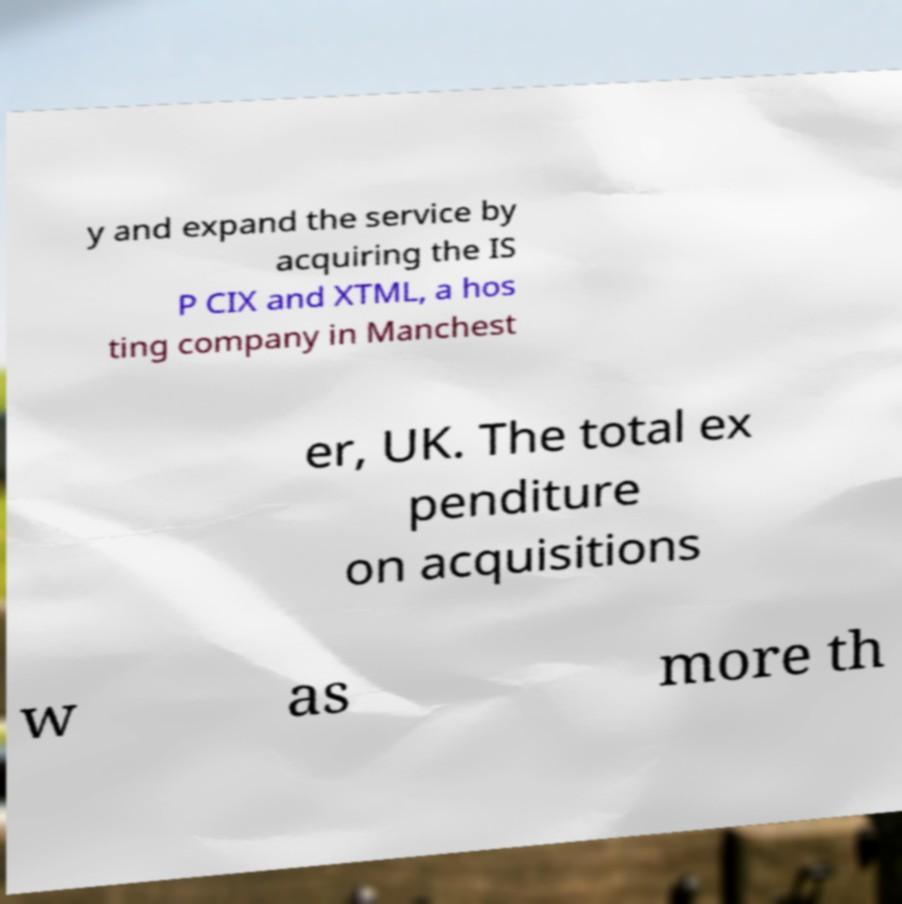Can you read and provide the text displayed in the image?This photo seems to have some interesting text. Can you extract and type it out for me? y and expand the service by acquiring the IS P CIX and XTML, a hos ting company in Manchest er, UK. The total ex penditure on acquisitions w as more th 